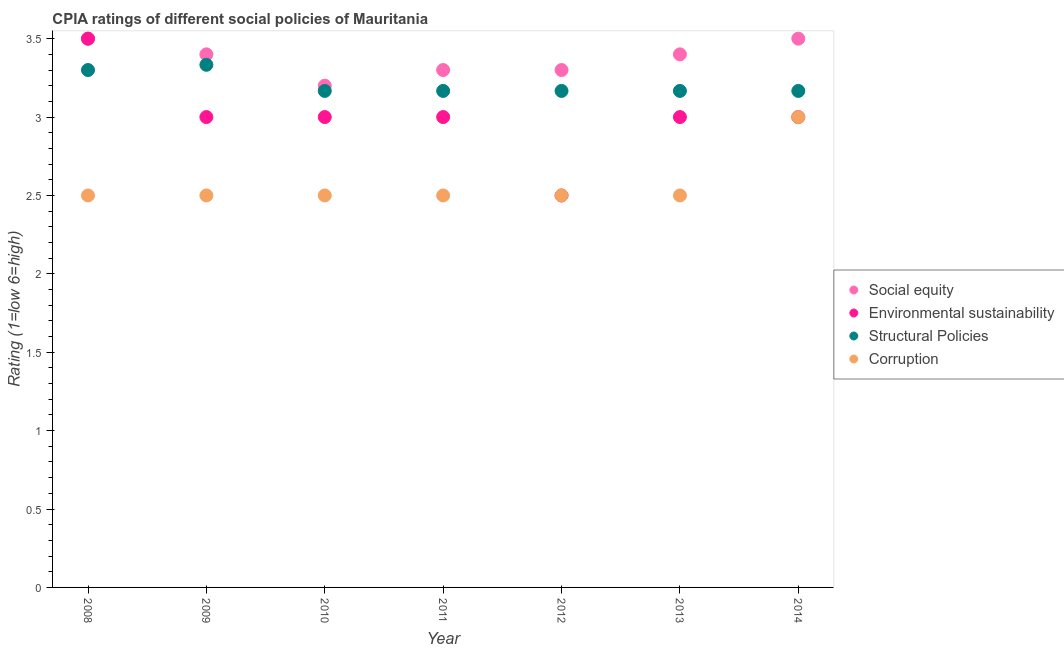How many different coloured dotlines are there?
Give a very brief answer. 4. Is the number of dotlines equal to the number of legend labels?
Provide a succinct answer. Yes. What is the cpia rating of social equity in 2014?
Make the answer very short. 3.5. Across all years, what is the maximum cpia rating of structural policies?
Keep it short and to the point. 3.33. What is the total cpia rating of environmental sustainability in the graph?
Your answer should be very brief. 21. What is the difference between the cpia rating of social equity in 2010 and that in 2011?
Keep it short and to the point. -0.1. What is the difference between the cpia rating of environmental sustainability in 2010 and the cpia rating of corruption in 2014?
Keep it short and to the point. 0. What is the average cpia rating of social equity per year?
Provide a succinct answer. 3.37. In the year 2010, what is the difference between the cpia rating of social equity and cpia rating of structural policies?
Give a very brief answer. 0.03. What is the ratio of the cpia rating of environmental sustainability in 2013 to that in 2014?
Give a very brief answer. 1. Is the difference between the cpia rating of social equity in 2010 and 2013 greater than the difference between the cpia rating of environmental sustainability in 2010 and 2013?
Offer a very short reply. No. What is the difference between the highest and the second highest cpia rating of corruption?
Make the answer very short. 0.5. What is the difference between the highest and the lowest cpia rating of social equity?
Your response must be concise. 0.3. In how many years, is the cpia rating of corruption greater than the average cpia rating of corruption taken over all years?
Your answer should be compact. 1. Is it the case that in every year, the sum of the cpia rating of structural policies and cpia rating of corruption is greater than the sum of cpia rating of social equity and cpia rating of environmental sustainability?
Give a very brief answer. No. Is it the case that in every year, the sum of the cpia rating of social equity and cpia rating of environmental sustainability is greater than the cpia rating of structural policies?
Your answer should be compact. Yes. How many dotlines are there?
Your response must be concise. 4. How are the legend labels stacked?
Keep it short and to the point. Vertical. What is the title of the graph?
Your answer should be compact. CPIA ratings of different social policies of Mauritania. What is the label or title of the Y-axis?
Ensure brevity in your answer.  Rating (1=low 6=high). What is the Rating (1=low 6=high) of Social equity in 2008?
Your answer should be very brief. 3.5. What is the Rating (1=low 6=high) in Corruption in 2008?
Your answer should be compact. 2.5. What is the Rating (1=low 6=high) of Social equity in 2009?
Provide a short and direct response. 3.4. What is the Rating (1=low 6=high) in Environmental sustainability in 2009?
Ensure brevity in your answer.  3. What is the Rating (1=low 6=high) of Structural Policies in 2009?
Offer a terse response. 3.33. What is the Rating (1=low 6=high) in Corruption in 2009?
Your answer should be compact. 2.5. What is the Rating (1=low 6=high) of Social equity in 2010?
Offer a very short reply. 3.2. What is the Rating (1=low 6=high) of Structural Policies in 2010?
Offer a very short reply. 3.17. What is the Rating (1=low 6=high) of Social equity in 2011?
Provide a short and direct response. 3.3. What is the Rating (1=low 6=high) in Structural Policies in 2011?
Give a very brief answer. 3.17. What is the Rating (1=low 6=high) of Corruption in 2011?
Make the answer very short. 2.5. What is the Rating (1=low 6=high) of Social equity in 2012?
Your answer should be compact. 3.3. What is the Rating (1=low 6=high) of Environmental sustainability in 2012?
Ensure brevity in your answer.  2.5. What is the Rating (1=low 6=high) in Structural Policies in 2012?
Make the answer very short. 3.17. What is the Rating (1=low 6=high) in Corruption in 2012?
Offer a very short reply. 2.5. What is the Rating (1=low 6=high) in Social equity in 2013?
Give a very brief answer. 3.4. What is the Rating (1=low 6=high) of Environmental sustainability in 2013?
Give a very brief answer. 3. What is the Rating (1=low 6=high) of Structural Policies in 2013?
Your answer should be compact. 3.17. What is the Rating (1=low 6=high) of Corruption in 2013?
Provide a succinct answer. 2.5. What is the Rating (1=low 6=high) of Environmental sustainability in 2014?
Your response must be concise. 3. What is the Rating (1=low 6=high) in Structural Policies in 2014?
Offer a very short reply. 3.17. What is the Rating (1=low 6=high) of Corruption in 2014?
Offer a very short reply. 3. Across all years, what is the maximum Rating (1=low 6=high) of Social equity?
Your answer should be very brief. 3.5. Across all years, what is the maximum Rating (1=low 6=high) of Structural Policies?
Offer a very short reply. 3.33. Across all years, what is the minimum Rating (1=low 6=high) in Social equity?
Your answer should be very brief. 3.2. Across all years, what is the minimum Rating (1=low 6=high) of Environmental sustainability?
Your response must be concise. 2.5. Across all years, what is the minimum Rating (1=low 6=high) of Structural Policies?
Your response must be concise. 3.17. Across all years, what is the minimum Rating (1=low 6=high) in Corruption?
Provide a short and direct response. 2.5. What is the total Rating (1=low 6=high) in Social equity in the graph?
Offer a very short reply. 23.6. What is the total Rating (1=low 6=high) of Environmental sustainability in the graph?
Ensure brevity in your answer.  21. What is the total Rating (1=low 6=high) in Structural Policies in the graph?
Your answer should be compact. 22.47. What is the total Rating (1=low 6=high) in Corruption in the graph?
Make the answer very short. 18. What is the difference between the Rating (1=low 6=high) of Environmental sustainability in 2008 and that in 2009?
Offer a very short reply. 0.5. What is the difference between the Rating (1=low 6=high) of Structural Policies in 2008 and that in 2009?
Make the answer very short. -0.03. What is the difference between the Rating (1=low 6=high) of Social equity in 2008 and that in 2010?
Provide a short and direct response. 0.3. What is the difference between the Rating (1=low 6=high) of Structural Policies in 2008 and that in 2010?
Provide a short and direct response. 0.13. What is the difference between the Rating (1=low 6=high) in Environmental sustainability in 2008 and that in 2011?
Give a very brief answer. 0.5. What is the difference between the Rating (1=low 6=high) in Structural Policies in 2008 and that in 2011?
Offer a very short reply. 0.13. What is the difference between the Rating (1=low 6=high) in Environmental sustainability in 2008 and that in 2012?
Your answer should be compact. 1. What is the difference between the Rating (1=low 6=high) in Structural Policies in 2008 and that in 2012?
Ensure brevity in your answer.  0.13. What is the difference between the Rating (1=low 6=high) of Social equity in 2008 and that in 2013?
Provide a succinct answer. 0.1. What is the difference between the Rating (1=low 6=high) in Environmental sustainability in 2008 and that in 2013?
Offer a terse response. 0.5. What is the difference between the Rating (1=low 6=high) of Structural Policies in 2008 and that in 2013?
Keep it short and to the point. 0.13. What is the difference between the Rating (1=low 6=high) in Social equity in 2008 and that in 2014?
Provide a short and direct response. 0. What is the difference between the Rating (1=low 6=high) in Environmental sustainability in 2008 and that in 2014?
Your answer should be very brief. 0.5. What is the difference between the Rating (1=low 6=high) of Structural Policies in 2008 and that in 2014?
Your response must be concise. 0.13. What is the difference between the Rating (1=low 6=high) in Environmental sustainability in 2009 and that in 2010?
Make the answer very short. 0. What is the difference between the Rating (1=low 6=high) of Corruption in 2009 and that in 2010?
Make the answer very short. 0. What is the difference between the Rating (1=low 6=high) of Environmental sustainability in 2009 and that in 2011?
Offer a terse response. 0. What is the difference between the Rating (1=low 6=high) in Environmental sustainability in 2009 and that in 2013?
Provide a succinct answer. 0. What is the difference between the Rating (1=low 6=high) of Social equity in 2009 and that in 2014?
Your response must be concise. -0.1. What is the difference between the Rating (1=low 6=high) in Structural Policies in 2009 and that in 2014?
Offer a terse response. 0.17. What is the difference between the Rating (1=low 6=high) in Corruption in 2009 and that in 2014?
Provide a succinct answer. -0.5. What is the difference between the Rating (1=low 6=high) of Social equity in 2010 and that in 2011?
Provide a succinct answer. -0.1. What is the difference between the Rating (1=low 6=high) in Social equity in 2010 and that in 2012?
Provide a short and direct response. -0.1. What is the difference between the Rating (1=low 6=high) in Environmental sustainability in 2010 and that in 2012?
Provide a short and direct response. 0.5. What is the difference between the Rating (1=low 6=high) of Corruption in 2010 and that in 2012?
Give a very brief answer. 0. What is the difference between the Rating (1=low 6=high) in Environmental sustainability in 2010 and that in 2013?
Ensure brevity in your answer.  0. What is the difference between the Rating (1=low 6=high) in Social equity in 2010 and that in 2014?
Keep it short and to the point. -0.3. What is the difference between the Rating (1=low 6=high) in Environmental sustainability in 2010 and that in 2014?
Your answer should be compact. 0. What is the difference between the Rating (1=low 6=high) in Social equity in 2011 and that in 2012?
Offer a terse response. 0. What is the difference between the Rating (1=low 6=high) of Environmental sustainability in 2011 and that in 2012?
Ensure brevity in your answer.  0.5. What is the difference between the Rating (1=low 6=high) in Structural Policies in 2011 and that in 2012?
Give a very brief answer. 0. What is the difference between the Rating (1=low 6=high) in Corruption in 2011 and that in 2012?
Your response must be concise. 0. What is the difference between the Rating (1=low 6=high) in Social equity in 2011 and that in 2013?
Keep it short and to the point. -0.1. What is the difference between the Rating (1=low 6=high) in Structural Policies in 2011 and that in 2013?
Make the answer very short. 0. What is the difference between the Rating (1=low 6=high) in Corruption in 2011 and that in 2013?
Make the answer very short. 0. What is the difference between the Rating (1=low 6=high) in Social equity in 2011 and that in 2014?
Your answer should be compact. -0.2. What is the difference between the Rating (1=low 6=high) in Corruption in 2011 and that in 2014?
Your answer should be compact. -0.5. What is the difference between the Rating (1=low 6=high) of Structural Policies in 2012 and that in 2013?
Ensure brevity in your answer.  0. What is the difference between the Rating (1=low 6=high) in Corruption in 2012 and that in 2013?
Ensure brevity in your answer.  0. What is the difference between the Rating (1=low 6=high) in Environmental sustainability in 2012 and that in 2014?
Offer a very short reply. -0.5. What is the difference between the Rating (1=low 6=high) of Corruption in 2012 and that in 2014?
Make the answer very short. -0.5. What is the difference between the Rating (1=low 6=high) of Corruption in 2013 and that in 2014?
Give a very brief answer. -0.5. What is the difference between the Rating (1=low 6=high) in Social equity in 2008 and the Rating (1=low 6=high) in Environmental sustainability in 2009?
Ensure brevity in your answer.  0.5. What is the difference between the Rating (1=low 6=high) in Social equity in 2008 and the Rating (1=low 6=high) in Structural Policies in 2009?
Keep it short and to the point. 0.17. What is the difference between the Rating (1=low 6=high) of Social equity in 2008 and the Rating (1=low 6=high) of Corruption in 2009?
Your answer should be very brief. 1. What is the difference between the Rating (1=low 6=high) of Environmental sustainability in 2008 and the Rating (1=low 6=high) of Structural Policies in 2009?
Provide a short and direct response. 0.17. What is the difference between the Rating (1=low 6=high) of Environmental sustainability in 2008 and the Rating (1=low 6=high) of Corruption in 2009?
Offer a very short reply. 1. What is the difference between the Rating (1=low 6=high) of Structural Policies in 2008 and the Rating (1=low 6=high) of Corruption in 2009?
Offer a terse response. 0.8. What is the difference between the Rating (1=low 6=high) in Social equity in 2008 and the Rating (1=low 6=high) in Environmental sustainability in 2010?
Provide a succinct answer. 0.5. What is the difference between the Rating (1=low 6=high) in Social equity in 2008 and the Rating (1=low 6=high) in Structural Policies in 2010?
Ensure brevity in your answer.  0.33. What is the difference between the Rating (1=low 6=high) in Environmental sustainability in 2008 and the Rating (1=low 6=high) in Structural Policies in 2010?
Your answer should be very brief. 0.33. What is the difference between the Rating (1=low 6=high) in Structural Policies in 2008 and the Rating (1=low 6=high) in Corruption in 2010?
Offer a terse response. 0.8. What is the difference between the Rating (1=low 6=high) in Social equity in 2008 and the Rating (1=low 6=high) in Structural Policies in 2011?
Give a very brief answer. 0.33. What is the difference between the Rating (1=low 6=high) in Environmental sustainability in 2008 and the Rating (1=low 6=high) in Structural Policies in 2011?
Your answer should be compact. 0.33. What is the difference between the Rating (1=low 6=high) in Social equity in 2008 and the Rating (1=low 6=high) in Corruption in 2012?
Provide a short and direct response. 1. What is the difference between the Rating (1=low 6=high) of Environmental sustainability in 2008 and the Rating (1=low 6=high) of Corruption in 2012?
Keep it short and to the point. 1. What is the difference between the Rating (1=low 6=high) in Social equity in 2008 and the Rating (1=low 6=high) in Corruption in 2013?
Give a very brief answer. 1. What is the difference between the Rating (1=low 6=high) of Social equity in 2008 and the Rating (1=low 6=high) of Environmental sustainability in 2014?
Your answer should be compact. 0.5. What is the difference between the Rating (1=low 6=high) of Environmental sustainability in 2008 and the Rating (1=low 6=high) of Structural Policies in 2014?
Your answer should be very brief. 0.33. What is the difference between the Rating (1=low 6=high) in Structural Policies in 2008 and the Rating (1=low 6=high) in Corruption in 2014?
Give a very brief answer. 0.3. What is the difference between the Rating (1=low 6=high) of Social equity in 2009 and the Rating (1=low 6=high) of Structural Policies in 2010?
Your answer should be very brief. 0.23. What is the difference between the Rating (1=low 6=high) of Social equity in 2009 and the Rating (1=low 6=high) of Corruption in 2010?
Offer a terse response. 0.9. What is the difference between the Rating (1=low 6=high) in Environmental sustainability in 2009 and the Rating (1=low 6=high) in Structural Policies in 2010?
Provide a succinct answer. -0.17. What is the difference between the Rating (1=low 6=high) in Environmental sustainability in 2009 and the Rating (1=low 6=high) in Corruption in 2010?
Provide a short and direct response. 0.5. What is the difference between the Rating (1=low 6=high) of Structural Policies in 2009 and the Rating (1=low 6=high) of Corruption in 2010?
Offer a very short reply. 0.83. What is the difference between the Rating (1=low 6=high) in Social equity in 2009 and the Rating (1=low 6=high) in Structural Policies in 2011?
Offer a terse response. 0.23. What is the difference between the Rating (1=low 6=high) of Social equity in 2009 and the Rating (1=low 6=high) of Corruption in 2011?
Give a very brief answer. 0.9. What is the difference between the Rating (1=low 6=high) of Environmental sustainability in 2009 and the Rating (1=low 6=high) of Structural Policies in 2011?
Offer a very short reply. -0.17. What is the difference between the Rating (1=low 6=high) in Structural Policies in 2009 and the Rating (1=low 6=high) in Corruption in 2011?
Your response must be concise. 0.83. What is the difference between the Rating (1=low 6=high) in Social equity in 2009 and the Rating (1=low 6=high) in Environmental sustainability in 2012?
Ensure brevity in your answer.  0.9. What is the difference between the Rating (1=low 6=high) of Social equity in 2009 and the Rating (1=low 6=high) of Structural Policies in 2012?
Your answer should be very brief. 0.23. What is the difference between the Rating (1=low 6=high) in Social equity in 2009 and the Rating (1=low 6=high) in Corruption in 2012?
Offer a terse response. 0.9. What is the difference between the Rating (1=low 6=high) of Structural Policies in 2009 and the Rating (1=low 6=high) of Corruption in 2012?
Ensure brevity in your answer.  0.83. What is the difference between the Rating (1=low 6=high) of Social equity in 2009 and the Rating (1=low 6=high) of Environmental sustainability in 2013?
Ensure brevity in your answer.  0.4. What is the difference between the Rating (1=low 6=high) of Social equity in 2009 and the Rating (1=low 6=high) of Structural Policies in 2013?
Offer a terse response. 0.23. What is the difference between the Rating (1=low 6=high) in Environmental sustainability in 2009 and the Rating (1=low 6=high) in Structural Policies in 2013?
Ensure brevity in your answer.  -0.17. What is the difference between the Rating (1=low 6=high) in Environmental sustainability in 2009 and the Rating (1=low 6=high) in Corruption in 2013?
Your answer should be compact. 0.5. What is the difference between the Rating (1=low 6=high) in Social equity in 2009 and the Rating (1=low 6=high) in Environmental sustainability in 2014?
Provide a short and direct response. 0.4. What is the difference between the Rating (1=low 6=high) of Social equity in 2009 and the Rating (1=low 6=high) of Structural Policies in 2014?
Provide a succinct answer. 0.23. What is the difference between the Rating (1=low 6=high) in Social equity in 2009 and the Rating (1=low 6=high) in Corruption in 2014?
Ensure brevity in your answer.  0.4. What is the difference between the Rating (1=low 6=high) in Environmental sustainability in 2009 and the Rating (1=low 6=high) in Structural Policies in 2014?
Offer a very short reply. -0.17. What is the difference between the Rating (1=low 6=high) of Environmental sustainability in 2009 and the Rating (1=low 6=high) of Corruption in 2014?
Provide a short and direct response. 0. What is the difference between the Rating (1=low 6=high) of Social equity in 2010 and the Rating (1=low 6=high) of Structural Policies in 2011?
Provide a short and direct response. 0.03. What is the difference between the Rating (1=low 6=high) of Social equity in 2010 and the Rating (1=low 6=high) of Environmental sustainability in 2012?
Provide a short and direct response. 0.7. What is the difference between the Rating (1=low 6=high) in Social equity in 2010 and the Rating (1=low 6=high) in Structural Policies in 2012?
Make the answer very short. 0.03. What is the difference between the Rating (1=low 6=high) in Social equity in 2010 and the Rating (1=low 6=high) in Environmental sustainability in 2013?
Ensure brevity in your answer.  0.2. What is the difference between the Rating (1=low 6=high) in Social equity in 2010 and the Rating (1=low 6=high) in Corruption in 2013?
Provide a succinct answer. 0.7. What is the difference between the Rating (1=low 6=high) in Environmental sustainability in 2010 and the Rating (1=low 6=high) in Structural Policies in 2013?
Your response must be concise. -0.17. What is the difference between the Rating (1=low 6=high) in Environmental sustainability in 2010 and the Rating (1=low 6=high) in Corruption in 2013?
Give a very brief answer. 0.5. What is the difference between the Rating (1=low 6=high) in Structural Policies in 2010 and the Rating (1=low 6=high) in Corruption in 2013?
Provide a succinct answer. 0.67. What is the difference between the Rating (1=low 6=high) of Social equity in 2010 and the Rating (1=low 6=high) of Corruption in 2014?
Ensure brevity in your answer.  0.2. What is the difference between the Rating (1=low 6=high) of Environmental sustainability in 2010 and the Rating (1=low 6=high) of Corruption in 2014?
Your answer should be compact. 0. What is the difference between the Rating (1=low 6=high) of Structural Policies in 2010 and the Rating (1=low 6=high) of Corruption in 2014?
Provide a succinct answer. 0.17. What is the difference between the Rating (1=low 6=high) in Social equity in 2011 and the Rating (1=low 6=high) in Structural Policies in 2012?
Provide a short and direct response. 0.13. What is the difference between the Rating (1=low 6=high) of Social equity in 2011 and the Rating (1=low 6=high) of Corruption in 2012?
Provide a short and direct response. 0.8. What is the difference between the Rating (1=low 6=high) in Social equity in 2011 and the Rating (1=low 6=high) in Structural Policies in 2013?
Ensure brevity in your answer.  0.13. What is the difference between the Rating (1=low 6=high) of Social equity in 2011 and the Rating (1=low 6=high) of Corruption in 2013?
Your answer should be compact. 0.8. What is the difference between the Rating (1=low 6=high) in Environmental sustainability in 2011 and the Rating (1=low 6=high) in Corruption in 2013?
Provide a succinct answer. 0.5. What is the difference between the Rating (1=low 6=high) of Structural Policies in 2011 and the Rating (1=low 6=high) of Corruption in 2013?
Offer a very short reply. 0.67. What is the difference between the Rating (1=low 6=high) of Social equity in 2011 and the Rating (1=low 6=high) of Structural Policies in 2014?
Ensure brevity in your answer.  0.13. What is the difference between the Rating (1=low 6=high) of Social equity in 2012 and the Rating (1=low 6=high) of Environmental sustainability in 2013?
Your response must be concise. 0.3. What is the difference between the Rating (1=low 6=high) in Social equity in 2012 and the Rating (1=low 6=high) in Structural Policies in 2013?
Provide a short and direct response. 0.13. What is the difference between the Rating (1=low 6=high) in Environmental sustainability in 2012 and the Rating (1=low 6=high) in Structural Policies in 2013?
Your answer should be very brief. -0.67. What is the difference between the Rating (1=low 6=high) in Environmental sustainability in 2012 and the Rating (1=low 6=high) in Corruption in 2013?
Provide a succinct answer. 0. What is the difference between the Rating (1=low 6=high) in Structural Policies in 2012 and the Rating (1=low 6=high) in Corruption in 2013?
Provide a succinct answer. 0.67. What is the difference between the Rating (1=low 6=high) in Social equity in 2012 and the Rating (1=low 6=high) in Structural Policies in 2014?
Ensure brevity in your answer.  0.13. What is the difference between the Rating (1=low 6=high) in Environmental sustainability in 2012 and the Rating (1=low 6=high) in Structural Policies in 2014?
Provide a short and direct response. -0.67. What is the difference between the Rating (1=low 6=high) in Social equity in 2013 and the Rating (1=low 6=high) in Environmental sustainability in 2014?
Make the answer very short. 0.4. What is the difference between the Rating (1=low 6=high) in Social equity in 2013 and the Rating (1=low 6=high) in Structural Policies in 2014?
Ensure brevity in your answer.  0.23. What is the difference between the Rating (1=low 6=high) of Environmental sustainability in 2013 and the Rating (1=low 6=high) of Structural Policies in 2014?
Your response must be concise. -0.17. What is the average Rating (1=low 6=high) in Social equity per year?
Offer a terse response. 3.37. What is the average Rating (1=low 6=high) of Structural Policies per year?
Provide a succinct answer. 3.21. What is the average Rating (1=low 6=high) in Corruption per year?
Your answer should be very brief. 2.57. In the year 2008, what is the difference between the Rating (1=low 6=high) of Social equity and Rating (1=low 6=high) of Environmental sustainability?
Offer a very short reply. 0. In the year 2008, what is the difference between the Rating (1=low 6=high) in Social equity and Rating (1=low 6=high) in Structural Policies?
Make the answer very short. 0.2. In the year 2008, what is the difference between the Rating (1=low 6=high) in Social equity and Rating (1=low 6=high) in Corruption?
Make the answer very short. 1. In the year 2008, what is the difference between the Rating (1=low 6=high) of Environmental sustainability and Rating (1=low 6=high) of Corruption?
Your answer should be very brief. 1. In the year 2008, what is the difference between the Rating (1=low 6=high) of Structural Policies and Rating (1=low 6=high) of Corruption?
Provide a short and direct response. 0.8. In the year 2009, what is the difference between the Rating (1=low 6=high) of Social equity and Rating (1=low 6=high) of Structural Policies?
Give a very brief answer. 0.07. In the year 2009, what is the difference between the Rating (1=low 6=high) in Environmental sustainability and Rating (1=low 6=high) in Structural Policies?
Offer a very short reply. -0.33. In the year 2009, what is the difference between the Rating (1=low 6=high) in Environmental sustainability and Rating (1=low 6=high) in Corruption?
Your answer should be compact. 0.5. In the year 2010, what is the difference between the Rating (1=low 6=high) in Social equity and Rating (1=low 6=high) in Environmental sustainability?
Your answer should be very brief. 0.2. In the year 2010, what is the difference between the Rating (1=low 6=high) of Environmental sustainability and Rating (1=low 6=high) of Corruption?
Keep it short and to the point. 0.5. In the year 2011, what is the difference between the Rating (1=low 6=high) in Social equity and Rating (1=low 6=high) in Structural Policies?
Provide a succinct answer. 0.13. In the year 2011, what is the difference between the Rating (1=low 6=high) of Environmental sustainability and Rating (1=low 6=high) of Structural Policies?
Offer a terse response. -0.17. In the year 2011, what is the difference between the Rating (1=low 6=high) of Environmental sustainability and Rating (1=low 6=high) of Corruption?
Provide a succinct answer. 0.5. In the year 2012, what is the difference between the Rating (1=low 6=high) in Social equity and Rating (1=low 6=high) in Structural Policies?
Provide a short and direct response. 0.13. In the year 2012, what is the difference between the Rating (1=low 6=high) of Environmental sustainability and Rating (1=low 6=high) of Structural Policies?
Keep it short and to the point. -0.67. In the year 2013, what is the difference between the Rating (1=low 6=high) in Social equity and Rating (1=low 6=high) in Structural Policies?
Your response must be concise. 0.23. In the year 2013, what is the difference between the Rating (1=low 6=high) of Environmental sustainability and Rating (1=low 6=high) of Structural Policies?
Your response must be concise. -0.17. In the year 2013, what is the difference between the Rating (1=low 6=high) in Environmental sustainability and Rating (1=low 6=high) in Corruption?
Keep it short and to the point. 0.5. In the year 2013, what is the difference between the Rating (1=low 6=high) of Structural Policies and Rating (1=low 6=high) of Corruption?
Your answer should be compact. 0.67. In the year 2014, what is the difference between the Rating (1=low 6=high) in Structural Policies and Rating (1=low 6=high) in Corruption?
Provide a short and direct response. 0.17. What is the ratio of the Rating (1=low 6=high) of Social equity in 2008 to that in 2009?
Offer a very short reply. 1.03. What is the ratio of the Rating (1=low 6=high) of Structural Policies in 2008 to that in 2009?
Make the answer very short. 0.99. What is the ratio of the Rating (1=low 6=high) of Social equity in 2008 to that in 2010?
Provide a short and direct response. 1.09. What is the ratio of the Rating (1=low 6=high) of Structural Policies in 2008 to that in 2010?
Make the answer very short. 1.04. What is the ratio of the Rating (1=low 6=high) of Corruption in 2008 to that in 2010?
Keep it short and to the point. 1. What is the ratio of the Rating (1=low 6=high) in Social equity in 2008 to that in 2011?
Make the answer very short. 1.06. What is the ratio of the Rating (1=low 6=high) of Structural Policies in 2008 to that in 2011?
Provide a succinct answer. 1.04. What is the ratio of the Rating (1=low 6=high) in Social equity in 2008 to that in 2012?
Your answer should be very brief. 1.06. What is the ratio of the Rating (1=low 6=high) of Structural Policies in 2008 to that in 2012?
Offer a very short reply. 1.04. What is the ratio of the Rating (1=low 6=high) of Corruption in 2008 to that in 2012?
Provide a short and direct response. 1. What is the ratio of the Rating (1=low 6=high) of Social equity in 2008 to that in 2013?
Give a very brief answer. 1.03. What is the ratio of the Rating (1=low 6=high) in Structural Policies in 2008 to that in 2013?
Your answer should be very brief. 1.04. What is the ratio of the Rating (1=low 6=high) in Corruption in 2008 to that in 2013?
Keep it short and to the point. 1. What is the ratio of the Rating (1=low 6=high) of Social equity in 2008 to that in 2014?
Provide a short and direct response. 1. What is the ratio of the Rating (1=low 6=high) in Environmental sustainability in 2008 to that in 2014?
Provide a short and direct response. 1.17. What is the ratio of the Rating (1=low 6=high) in Structural Policies in 2008 to that in 2014?
Give a very brief answer. 1.04. What is the ratio of the Rating (1=low 6=high) of Corruption in 2008 to that in 2014?
Provide a short and direct response. 0.83. What is the ratio of the Rating (1=low 6=high) of Environmental sustainability in 2009 to that in 2010?
Provide a succinct answer. 1. What is the ratio of the Rating (1=low 6=high) in Structural Policies in 2009 to that in 2010?
Provide a short and direct response. 1.05. What is the ratio of the Rating (1=low 6=high) of Corruption in 2009 to that in 2010?
Offer a very short reply. 1. What is the ratio of the Rating (1=low 6=high) of Social equity in 2009 to that in 2011?
Ensure brevity in your answer.  1.03. What is the ratio of the Rating (1=low 6=high) of Structural Policies in 2009 to that in 2011?
Your response must be concise. 1.05. What is the ratio of the Rating (1=low 6=high) of Corruption in 2009 to that in 2011?
Give a very brief answer. 1. What is the ratio of the Rating (1=low 6=high) of Social equity in 2009 to that in 2012?
Keep it short and to the point. 1.03. What is the ratio of the Rating (1=low 6=high) of Structural Policies in 2009 to that in 2012?
Ensure brevity in your answer.  1.05. What is the ratio of the Rating (1=low 6=high) in Corruption in 2009 to that in 2012?
Make the answer very short. 1. What is the ratio of the Rating (1=low 6=high) in Structural Policies in 2009 to that in 2013?
Give a very brief answer. 1.05. What is the ratio of the Rating (1=low 6=high) of Corruption in 2009 to that in 2013?
Offer a terse response. 1. What is the ratio of the Rating (1=low 6=high) of Social equity in 2009 to that in 2014?
Offer a terse response. 0.97. What is the ratio of the Rating (1=low 6=high) in Environmental sustainability in 2009 to that in 2014?
Provide a succinct answer. 1. What is the ratio of the Rating (1=low 6=high) in Structural Policies in 2009 to that in 2014?
Make the answer very short. 1.05. What is the ratio of the Rating (1=low 6=high) of Social equity in 2010 to that in 2011?
Provide a succinct answer. 0.97. What is the ratio of the Rating (1=low 6=high) in Environmental sustainability in 2010 to that in 2011?
Offer a terse response. 1. What is the ratio of the Rating (1=low 6=high) of Corruption in 2010 to that in 2011?
Keep it short and to the point. 1. What is the ratio of the Rating (1=low 6=high) in Social equity in 2010 to that in 2012?
Offer a terse response. 0.97. What is the ratio of the Rating (1=low 6=high) of Corruption in 2010 to that in 2012?
Offer a terse response. 1. What is the ratio of the Rating (1=low 6=high) of Social equity in 2010 to that in 2013?
Make the answer very short. 0.94. What is the ratio of the Rating (1=low 6=high) of Environmental sustainability in 2010 to that in 2013?
Keep it short and to the point. 1. What is the ratio of the Rating (1=low 6=high) in Structural Policies in 2010 to that in 2013?
Your answer should be very brief. 1. What is the ratio of the Rating (1=low 6=high) of Corruption in 2010 to that in 2013?
Provide a succinct answer. 1. What is the ratio of the Rating (1=low 6=high) in Social equity in 2010 to that in 2014?
Your response must be concise. 0.91. What is the ratio of the Rating (1=low 6=high) of Social equity in 2011 to that in 2012?
Your answer should be compact. 1. What is the ratio of the Rating (1=low 6=high) in Social equity in 2011 to that in 2013?
Your response must be concise. 0.97. What is the ratio of the Rating (1=low 6=high) of Environmental sustainability in 2011 to that in 2013?
Your response must be concise. 1. What is the ratio of the Rating (1=low 6=high) in Structural Policies in 2011 to that in 2013?
Provide a succinct answer. 1. What is the ratio of the Rating (1=low 6=high) in Social equity in 2011 to that in 2014?
Your answer should be compact. 0.94. What is the ratio of the Rating (1=low 6=high) in Environmental sustainability in 2011 to that in 2014?
Offer a terse response. 1. What is the ratio of the Rating (1=low 6=high) of Structural Policies in 2011 to that in 2014?
Provide a short and direct response. 1. What is the ratio of the Rating (1=low 6=high) in Social equity in 2012 to that in 2013?
Your answer should be very brief. 0.97. What is the ratio of the Rating (1=low 6=high) of Environmental sustainability in 2012 to that in 2013?
Make the answer very short. 0.83. What is the ratio of the Rating (1=low 6=high) of Structural Policies in 2012 to that in 2013?
Your answer should be very brief. 1. What is the ratio of the Rating (1=low 6=high) in Social equity in 2012 to that in 2014?
Provide a succinct answer. 0.94. What is the ratio of the Rating (1=low 6=high) of Environmental sustainability in 2012 to that in 2014?
Give a very brief answer. 0.83. What is the ratio of the Rating (1=low 6=high) in Corruption in 2012 to that in 2014?
Offer a very short reply. 0.83. What is the ratio of the Rating (1=low 6=high) of Social equity in 2013 to that in 2014?
Your response must be concise. 0.97. What is the difference between the highest and the second highest Rating (1=low 6=high) of Structural Policies?
Make the answer very short. 0.03. What is the difference between the highest and the second highest Rating (1=low 6=high) in Corruption?
Give a very brief answer. 0.5. What is the difference between the highest and the lowest Rating (1=low 6=high) of Corruption?
Your answer should be very brief. 0.5. 